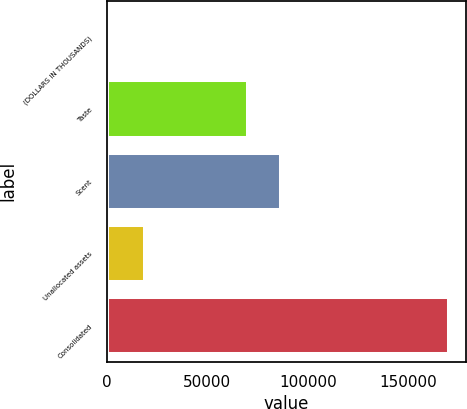<chart> <loc_0><loc_0><loc_500><loc_500><bar_chart><fcel>(DOLLARS IN THOUSANDS)<fcel>Taste<fcel>Scent<fcel>Unallocated assets<fcel>Consolidated<nl><fcel>2018<fcel>70028<fcel>86835.6<fcel>18825.6<fcel>170094<nl></chart> 